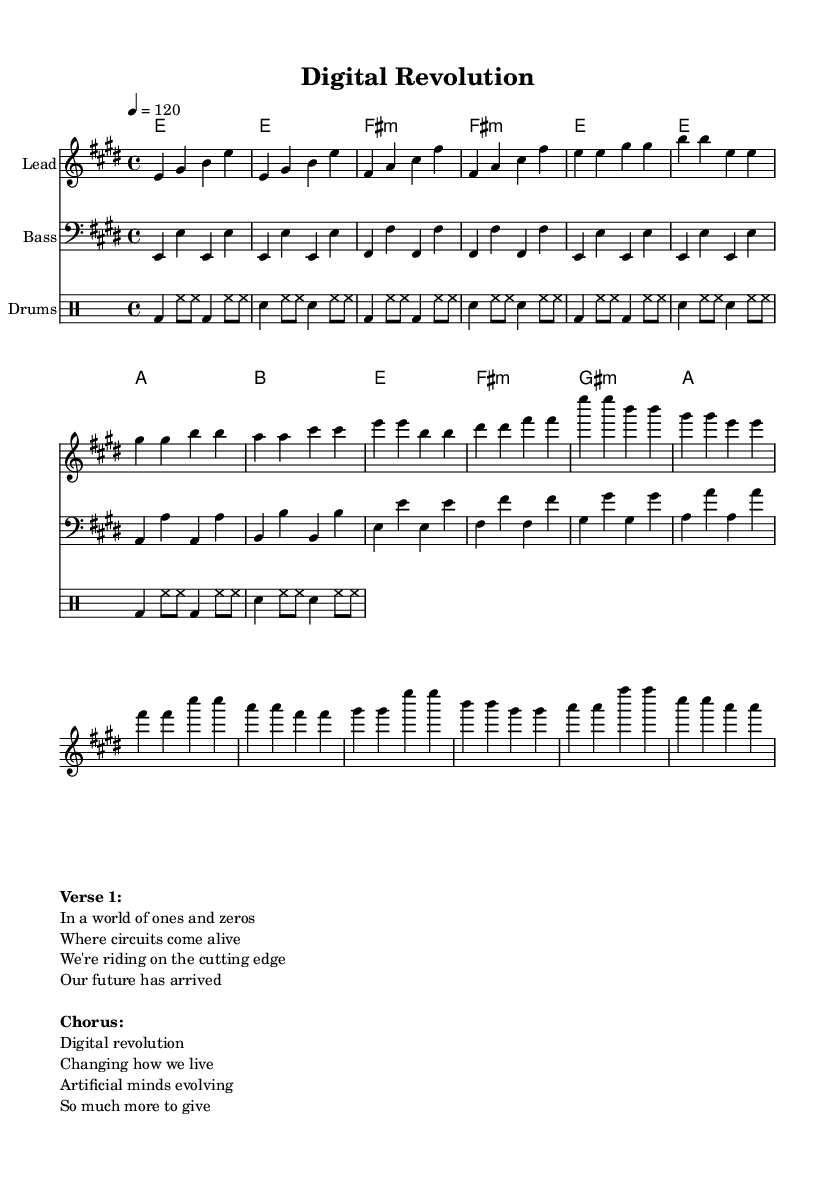What is the key signature of this music? The key signature is E major, which includes four sharps (F#, C#, G#, D#). This is determined by looking at the key signature indication at the beginning of the score.
Answer: E major What is the time signature used in this score? The time signature is 4/4, which is indicated at the beginning of the score. It means there are four beats in a measure, and the quarter note gets one beat.
Answer: 4/4 What is the tempo marking for this piece? The tempo marking is 120 beats per minute, as shown at the beginning of the score with the notation "4 = 120". This indicates how fast the piece should be played.
Answer: 120 How many measures are in the chorus section? The chorus section has four measures. Counting each measure in the annotated section reveals that it contains a total of four distinct measures, as indicated in the layout.
Answer: 4 What is the name of the song as per the header? The song title indicated in the header is "Digital Revolution". This is explicitly stated within the score's header section.
Answer: Digital Revolution Which section of the song has lyrics that mention "Artificial minds evolving"? The section containing the lyrics mentioning "Artificial minds evolving" is the chorus. This can be identified by analyzing the lyrics and noting their placement in the overall structure of the song.
Answer: Chorus 